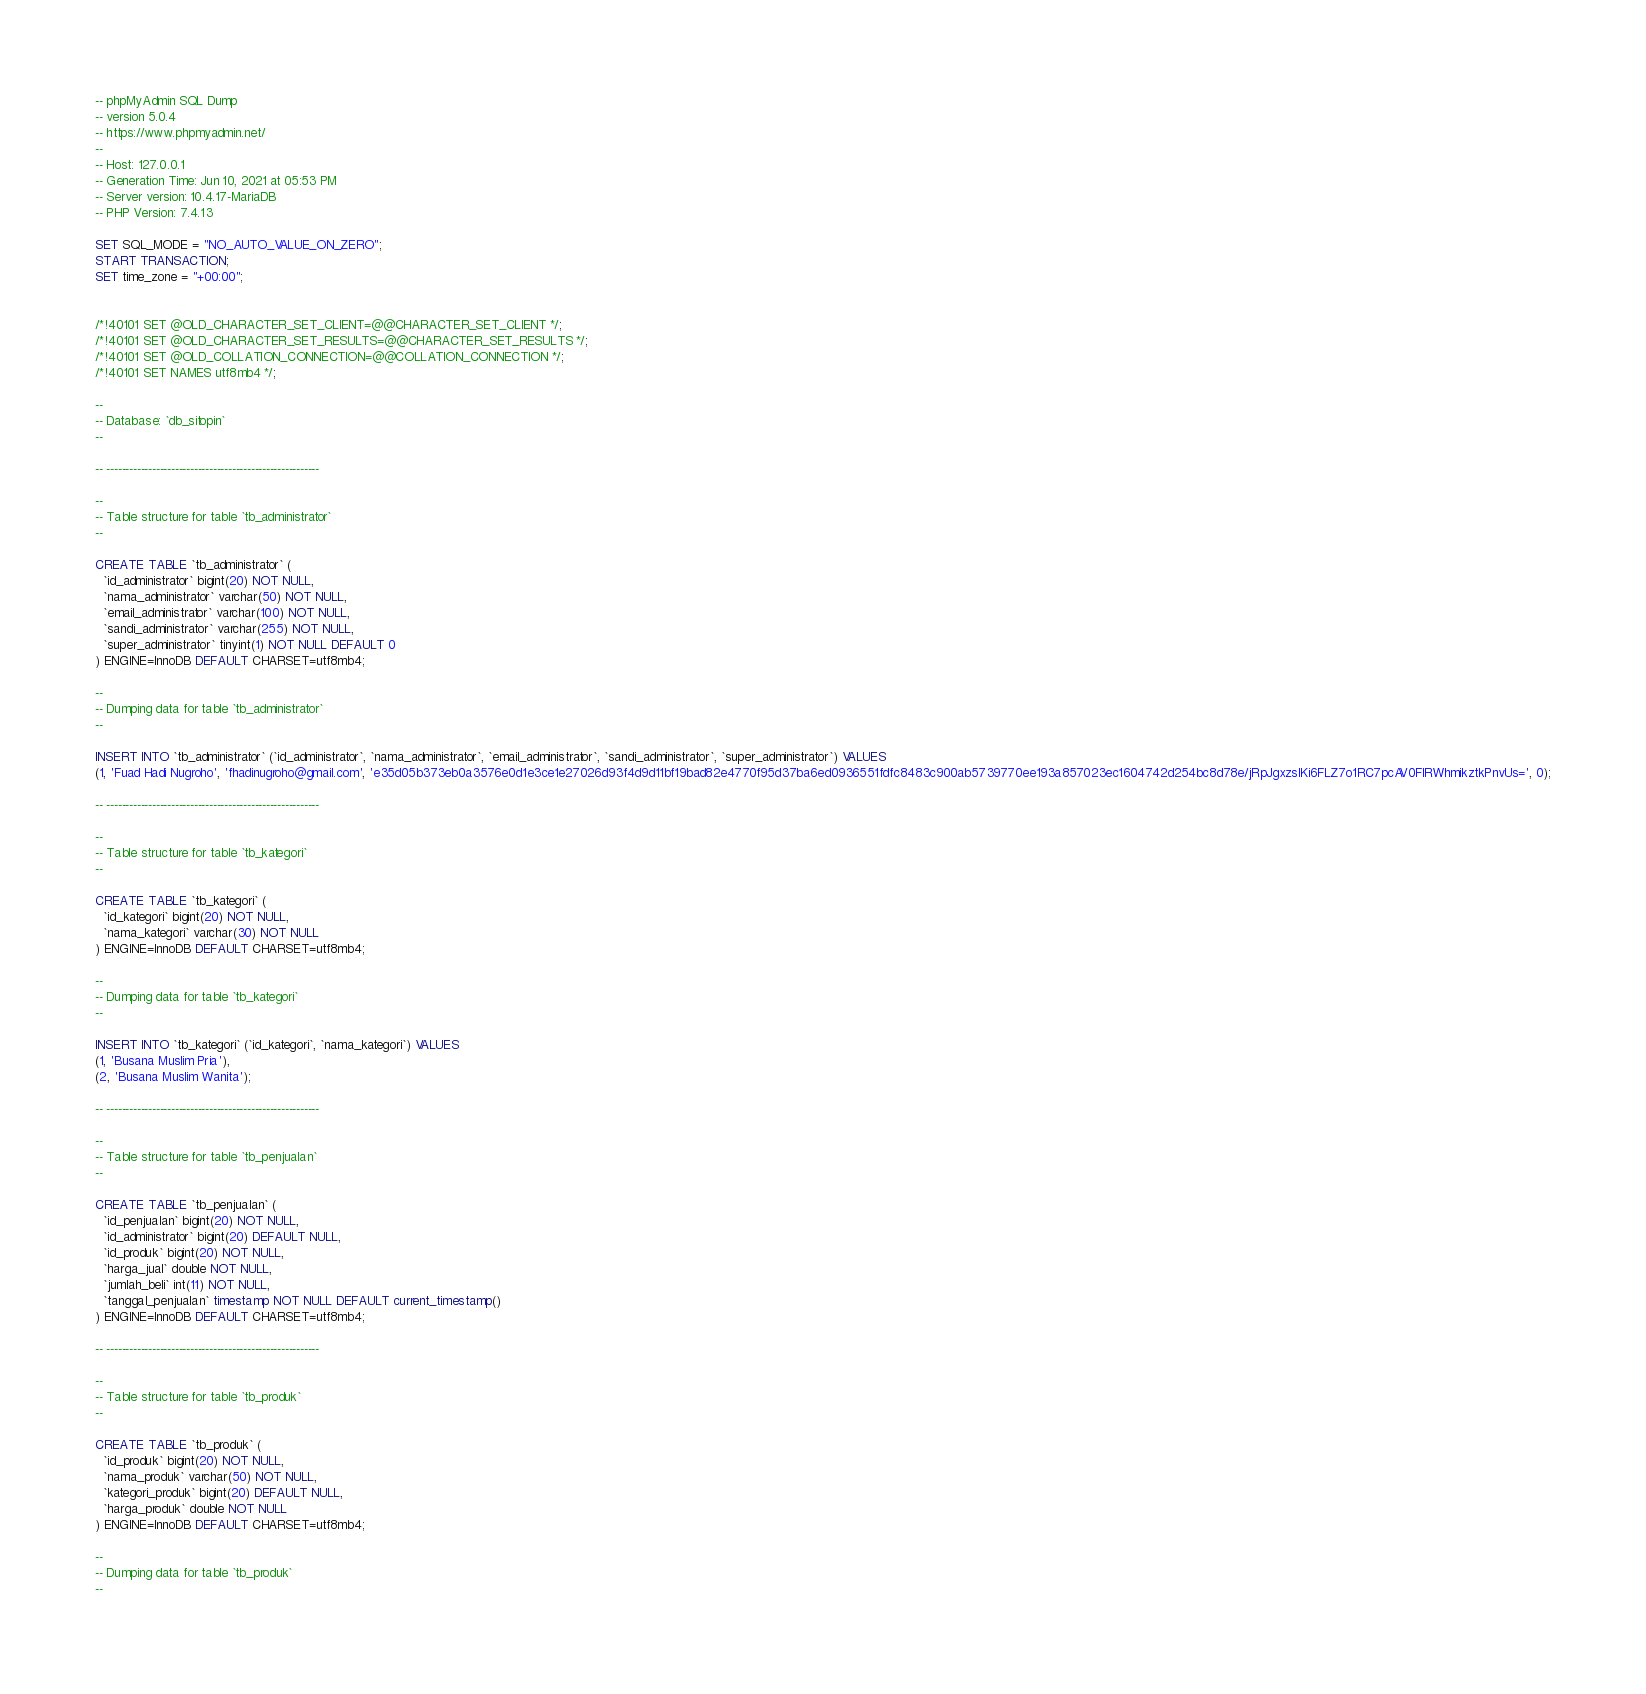Convert code to text. <code><loc_0><loc_0><loc_500><loc_500><_SQL_>-- phpMyAdmin SQL Dump
-- version 5.0.4
-- https://www.phpmyadmin.net/
--
-- Host: 127.0.0.1
-- Generation Time: Jun 10, 2021 at 05:53 PM
-- Server version: 10.4.17-MariaDB
-- PHP Version: 7.4.13

SET SQL_MODE = "NO_AUTO_VALUE_ON_ZERO";
START TRANSACTION;
SET time_zone = "+00:00";


/*!40101 SET @OLD_CHARACTER_SET_CLIENT=@@CHARACTER_SET_CLIENT */;
/*!40101 SET @OLD_CHARACTER_SET_RESULTS=@@CHARACTER_SET_RESULTS */;
/*!40101 SET @OLD_COLLATION_CONNECTION=@@COLLATION_CONNECTION */;
/*!40101 SET NAMES utf8mb4 */;

--
-- Database: `db_sitopin`
--

-- --------------------------------------------------------

--
-- Table structure for table `tb_administrator`
--

CREATE TABLE `tb_administrator` (
  `id_administrator` bigint(20) NOT NULL,
  `nama_administrator` varchar(50) NOT NULL,
  `email_administrator` varchar(100) NOT NULL,
  `sandi_administrator` varchar(255) NOT NULL,
  `super_administrator` tinyint(1) NOT NULL DEFAULT 0
) ENGINE=InnoDB DEFAULT CHARSET=utf8mb4;

--
-- Dumping data for table `tb_administrator`
--

INSERT INTO `tb_administrator` (`id_administrator`, `nama_administrator`, `email_administrator`, `sandi_administrator`, `super_administrator`) VALUES
(1, 'Fuad Hadi Nugroho', 'fhadinugroho@gmail.com', 'e35d05b373eb0a3576e0d1e3ce1e27026d93f4d9d11bf19bad82e4770f95d37ba6ed0936551fdfc8483c900ab5739770ee193a857023ec1604742d254bc8d78e/jRpJgxzslKi6FLZ7o1RC7pcAV0FlRWhmikztkPnvUs=', 0);

-- --------------------------------------------------------

--
-- Table structure for table `tb_kategori`
--

CREATE TABLE `tb_kategori` (
  `id_kategori` bigint(20) NOT NULL,
  `nama_kategori` varchar(30) NOT NULL
) ENGINE=InnoDB DEFAULT CHARSET=utf8mb4;

--
-- Dumping data for table `tb_kategori`
--

INSERT INTO `tb_kategori` (`id_kategori`, `nama_kategori`) VALUES
(1, 'Busana Muslim Pria'),
(2, 'Busana Muslim Wanita');

-- --------------------------------------------------------

--
-- Table structure for table `tb_penjualan`
--

CREATE TABLE `tb_penjualan` (
  `id_penjualan` bigint(20) NOT NULL,
  `id_administrator` bigint(20) DEFAULT NULL,
  `id_produk` bigint(20) NOT NULL,
  `harga_jual` double NOT NULL,
  `jumlah_beli` int(11) NOT NULL,
  `tanggal_penjualan` timestamp NOT NULL DEFAULT current_timestamp()
) ENGINE=InnoDB DEFAULT CHARSET=utf8mb4;

-- --------------------------------------------------------

--
-- Table structure for table `tb_produk`
--

CREATE TABLE `tb_produk` (
  `id_produk` bigint(20) NOT NULL,
  `nama_produk` varchar(50) NOT NULL,
  `kategori_produk` bigint(20) DEFAULT NULL,
  `harga_produk` double NOT NULL
) ENGINE=InnoDB DEFAULT CHARSET=utf8mb4;

--
-- Dumping data for table `tb_produk`
--
</code> 